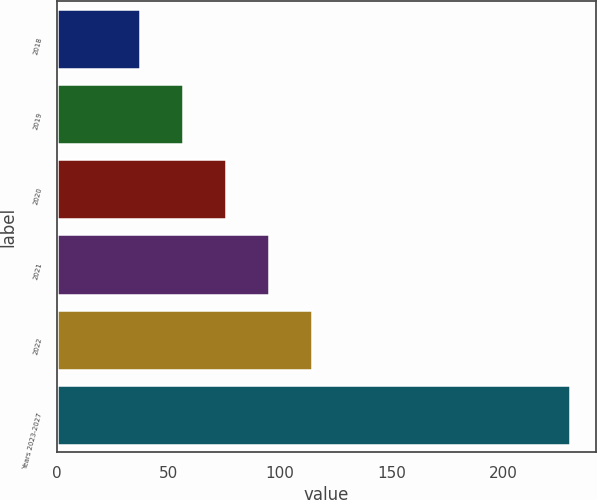Convert chart to OTSL. <chart><loc_0><loc_0><loc_500><loc_500><bar_chart><fcel>2018<fcel>2019<fcel>2020<fcel>2021<fcel>2022<fcel>Years 2023-2027<nl><fcel>37.4<fcel>56.65<fcel>75.9<fcel>95.15<fcel>114.4<fcel>229.9<nl></chart> 